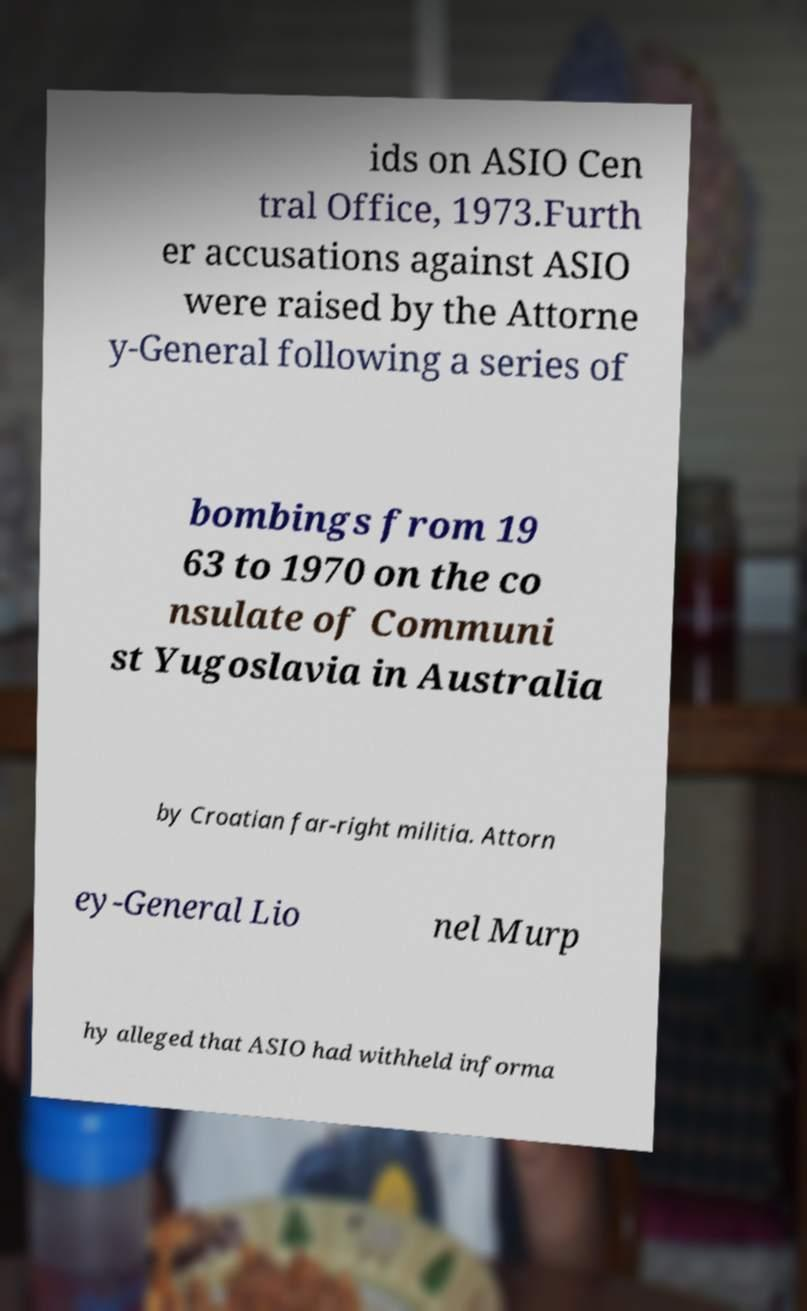Could you extract and type out the text from this image? ids on ASIO Cen tral Office, 1973.Furth er accusations against ASIO were raised by the Attorne y-General following a series of bombings from 19 63 to 1970 on the co nsulate of Communi st Yugoslavia in Australia by Croatian far-right militia. Attorn ey-General Lio nel Murp hy alleged that ASIO had withheld informa 